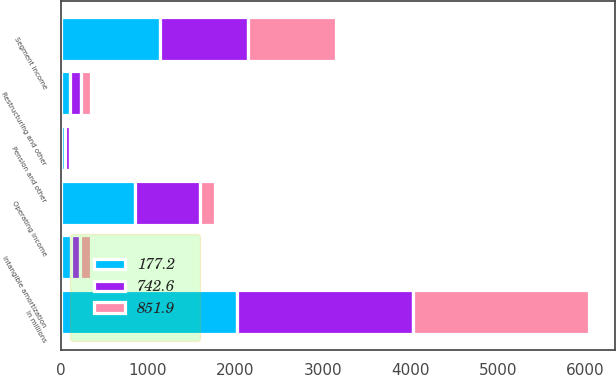<chart> <loc_0><loc_0><loc_500><loc_500><stacked_bar_chart><ecel><fcel>In millions<fcel>Segment income<fcel>Restructuring and other<fcel>Intangible amortization<fcel>Pension and other<fcel>Operating income<nl><fcel>851.9<fcel>2015<fcel>1001.2<fcel>120.9<fcel>121.4<fcel>23<fcel>177.2<nl><fcel>177.2<fcel>2014<fcel>1135.7<fcel>109.6<fcel>114<fcel>49.9<fcel>851.9<nl><fcel>742.6<fcel>2013<fcel>1013.2<fcel>119.9<fcel>110.9<fcel>63.2<fcel>742.6<nl></chart> 